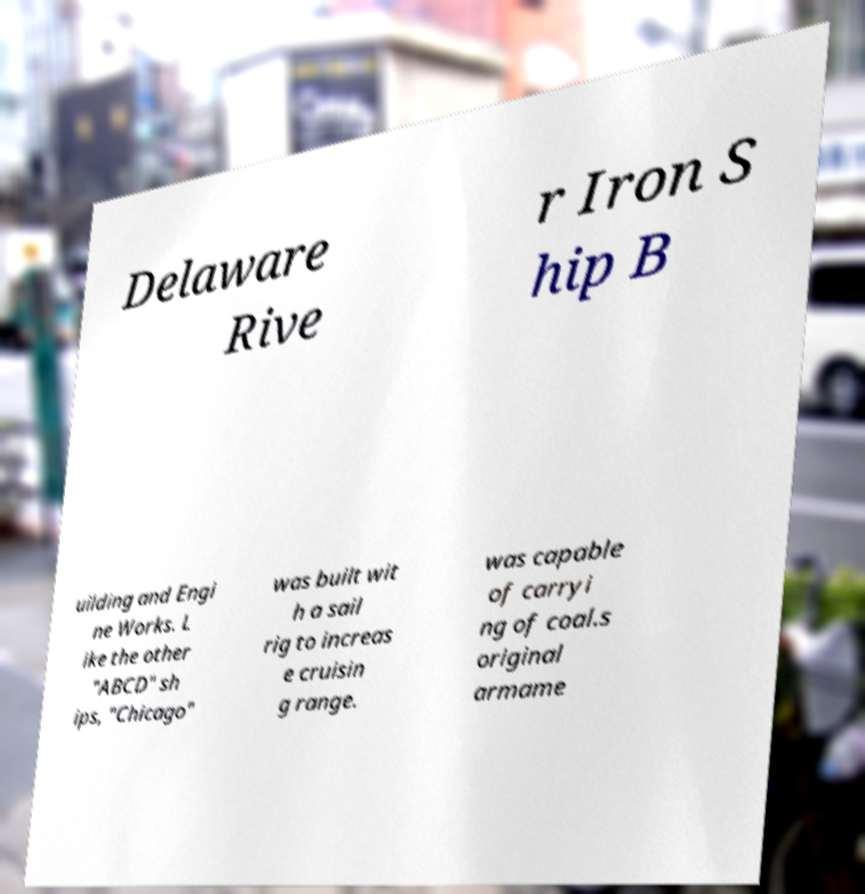Can you accurately transcribe the text from the provided image for me? Delaware Rive r Iron S hip B uilding and Engi ne Works. L ike the other "ABCD" sh ips, "Chicago" was built wit h a sail rig to increas e cruisin g range. was capable of carryi ng of coal.s original armame 